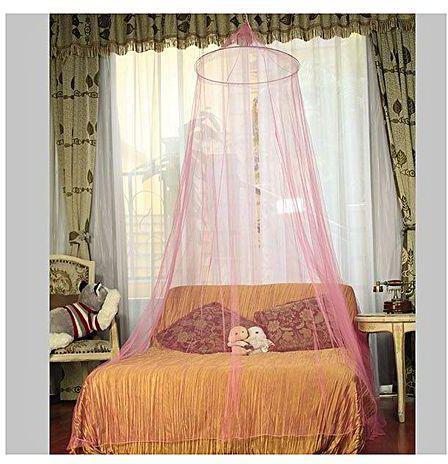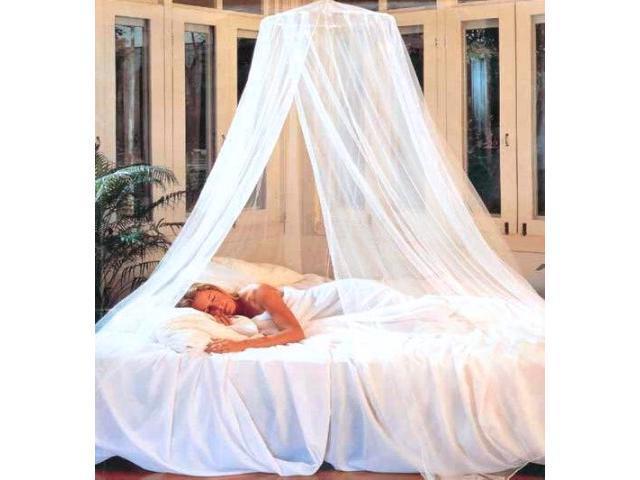The first image is the image on the left, the second image is the image on the right. Analyze the images presented: Is the assertion "Some of the sheets are blue." valid? Answer yes or no. No. 